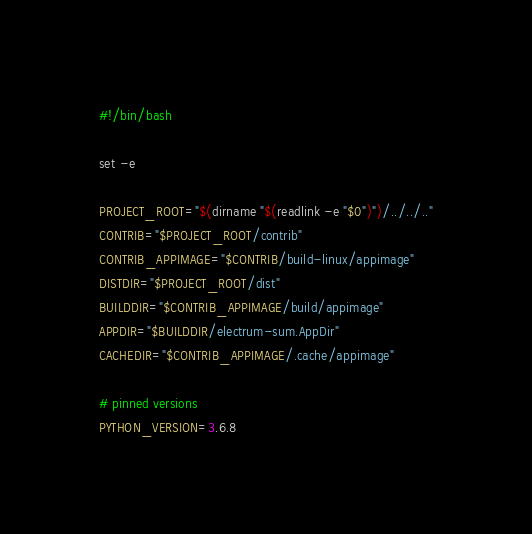<code> <loc_0><loc_0><loc_500><loc_500><_Bash_>#!/bin/bash

set -e

PROJECT_ROOT="$(dirname "$(readlink -e "$0")")/../../.."
CONTRIB="$PROJECT_ROOT/contrib"
CONTRIB_APPIMAGE="$CONTRIB/build-linux/appimage"
DISTDIR="$PROJECT_ROOT/dist"
BUILDDIR="$CONTRIB_APPIMAGE/build/appimage"
APPDIR="$BUILDDIR/electrum-sum.AppDir"
CACHEDIR="$CONTRIB_APPIMAGE/.cache/appimage"

# pinned versions
PYTHON_VERSION=3.6.8</code> 